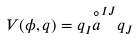Convert formula to latex. <formula><loc_0><loc_0><loc_500><loc_500>V ( \phi , q ) = q _ { I } { \stackrel { \circ } { a } } ^ { I J } q _ { J }</formula> 